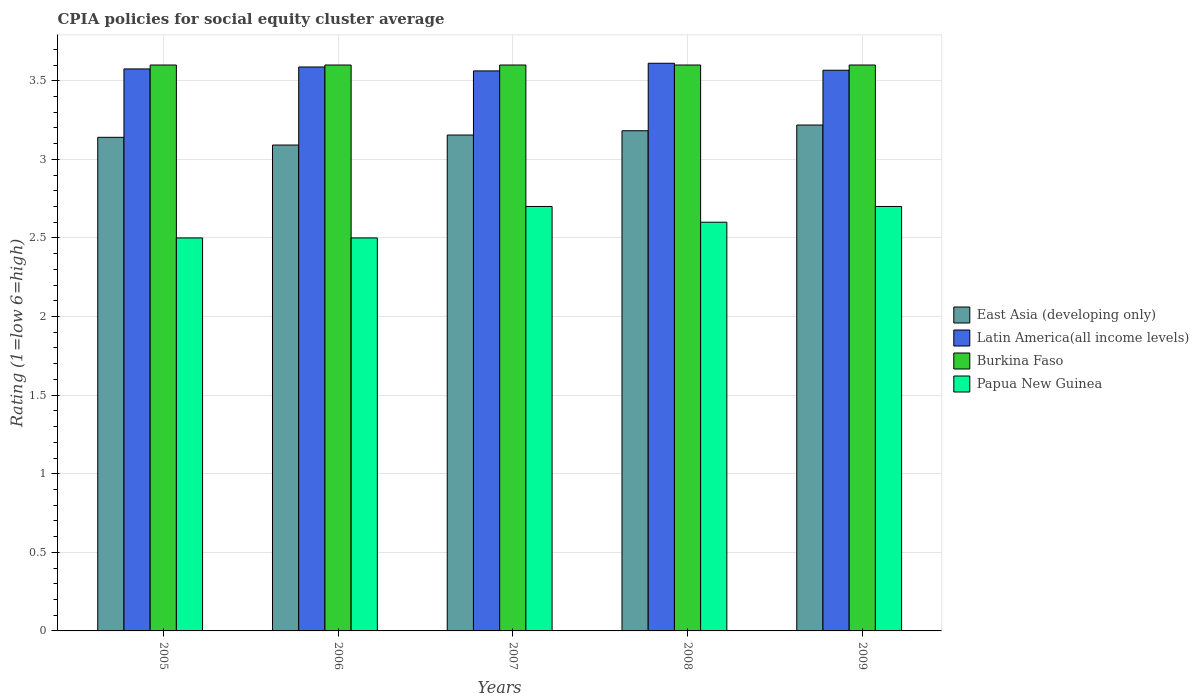How many different coloured bars are there?
Your answer should be compact. 4. How many groups of bars are there?
Your answer should be compact. 5. How many bars are there on the 3rd tick from the left?
Offer a terse response. 4. What is the label of the 4th group of bars from the left?
Give a very brief answer. 2008. In how many cases, is the number of bars for a given year not equal to the number of legend labels?
Provide a succinct answer. 0. In which year was the CPIA rating in Latin America(all income levels) maximum?
Offer a terse response. 2008. What is the total CPIA rating in Latin America(all income levels) in the graph?
Provide a succinct answer. 17.9. What is the difference between the CPIA rating in Burkina Faso in 2005 and that in 2006?
Give a very brief answer. 0. What is the difference between the CPIA rating in Papua New Guinea in 2005 and the CPIA rating in Latin America(all income levels) in 2009?
Offer a terse response. -1.07. In the year 2006, what is the difference between the CPIA rating in Latin America(all income levels) and CPIA rating in Burkina Faso?
Keep it short and to the point. -0.01. What is the ratio of the CPIA rating in Papua New Guinea in 2007 to that in 2008?
Make the answer very short. 1.04. Is the CPIA rating in Latin America(all income levels) in 2005 less than that in 2007?
Make the answer very short. No. Is the difference between the CPIA rating in Latin America(all income levels) in 2005 and 2008 greater than the difference between the CPIA rating in Burkina Faso in 2005 and 2008?
Provide a succinct answer. No. What is the difference between the highest and the second highest CPIA rating in Papua New Guinea?
Provide a succinct answer. 0. What is the difference between the highest and the lowest CPIA rating in Papua New Guinea?
Provide a succinct answer. 0.2. Is it the case that in every year, the sum of the CPIA rating in Papua New Guinea and CPIA rating in Burkina Faso is greater than the sum of CPIA rating in East Asia (developing only) and CPIA rating in Latin America(all income levels)?
Offer a very short reply. No. What does the 3rd bar from the left in 2008 represents?
Ensure brevity in your answer.  Burkina Faso. What does the 2nd bar from the right in 2006 represents?
Your answer should be very brief. Burkina Faso. How many years are there in the graph?
Provide a short and direct response. 5. Are the values on the major ticks of Y-axis written in scientific E-notation?
Your answer should be compact. No. Does the graph contain any zero values?
Your response must be concise. No. Does the graph contain grids?
Provide a succinct answer. Yes. How many legend labels are there?
Provide a succinct answer. 4. How are the legend labels stacked?
Offer a very short reply. Vertical. What is the title of the graph?
Ensure brevity in your answer.  CPIA policies for social equity cluster average. Does "Marshall Islands" appear as one of the legend labels in the graph?
Your response must be concise. No. What is the label or title of the X-axis?
Make the answer very short. Years. What is the label or title of the Y-axis?
Keep it short and to the point. Rating (1=low 6=high). What is the Rating (1=low 6=high) in East Asia (developing only) in 2005?
Give a very brief answer. 3.14. What is the Rating (1=low 6=high) in Latin America(all income levels) in 2005?
Keep it short and to the point. 3.58. What is the Rating (1=low 6=high) in Burkina Faso in 2005?
Provide a succinct answer. 3.6. What is the Rating (1=low 6=high) in Papua New Guinea in 2005?
Provide a short and direct response. 2.5. What is the Rating (1=low 6=high) in East Asia (developing only) in 2006?
Offer a terse response. 3.09. What is the Rating (1=low 6=high) in Latin America(all income levels) in 2006?
Your answer should be very brief. 3.59. What is the Rating (1=low 6=high) of Papua New Guinea in 2006?
Provide a succinct answer. 2.5. What is the Rating (1=low 6=high) in East Asia (developing only) in 2007?
Offer a terse response. 3.15. What is the Rating (1=low 6=high) of Latin America(all income levels) in 2007?
Keep it short and to the point. 3.56. What is the Rating (1=low 6=high) in Burkina Faso in 2007?
Ensure brevity in your answer.  3.6. What is the Rating (1=low 6=high) in East Asia (developing only) in 2008?
Make the answer very short. 3.18. What is the Rating (1=low 6=high) in Latin America(all income levels) in 2008?
Offer a terse response. 3.61. What is the Rating (1=low 6=high) in East Asia (developing only) in 2009?
Provide a succinct answer. 3.22. What is the Rating (1=low 6=high) in Latin America(all income levels) in 2009?
Ensure brevity in your answer.  3.57. What is the Rating (1=low 6=high) of Burkina Faso in 2009?
Give a very brief answer. 3.6. What is the Rating (1=low 6=high) in Papua New Guinea in 2009?
Offer a very short reply. 2.7. Across all years, what is the maximum Rating (1=low 6=high) of East Asia (developing only)?
Offer a very short reply. 3.22. Across all years, what is the maximum Rating (1=low 6=high) of Latin America(all income levels)?
Offer a very short reply. 3.61. Across all years, what is the maximum Rating (1=low 6=high) of Burkina Faso?
Ensure brevity in your answer.  3.6. Across all years, what is the minimum Rating (1=low 6=high) of East Asia (developing only)?
Ensure brevity in your answer.  3.09. Across all years, what is the minimum Rating (1=low 6=high) in Latin America(all income levels)?
Offer a very short reply. 3.56. What is the total Rating (1=low 6=high) of East Asia (developing only) in the graph?
Your response must be concise. 15.79. What is the total Rating (1=low 6=high) of Latin America(all income levels) in the graph?
Offer a terse response. 17.9. What is the difference between the Rating (1=low 6=high) of East Asia (developing only) in 2005 and that in 2006?
Your answer should be compact. 0.05. What is the difference between the Rating (1=low 6=high) in Latin America(all income levels) in 2005 and that in 2006?
Your answer should be very brief. -0.01. What is the difference between the Rating (1=low 6=high) in Burkina Faso in 2005 and that in 2006?
Your answer should be very brief. 0. What is the difference between the Rating (1=low 6=high) in Papua New Guinea in 2005 and that in 2006?
Give a very brief answer. 0. What is the difference between the Rating (1=low 6=high) in East Asia (developing only) in 2005 and that in 2007?
Your answer should be compact. -0.01. What is the difference between the Rating (1=low 6=high) of Latin America(all income levels) in 2005 and that in 2007?
Offer a very short reply. 0.01. What is the difference between the Rating (1=low 6=high) in Burkina Faso in 2005 and that in 2007?
Keep it short and to the point. 0. What is the difference between the Rating (1=low 6=high) in Papua New Guinea in 2005 and that in 2007?
Keep it short and to the point. -0.2. What is the difference between the Rating (1=low 6=high) of East Asia (developing only) in 2005 and that in 2008?
Give a very brief answer. -0.04. What is the difference between the Rating (1=low 6=high) in Latin America(all income levels) in 2005 and that in 2008?
Provide a succinct answer. -0.04. What is the difference between the Rating (1=low 6=high) in Burkina Faso in 2005 and that in 2008?
Give a very brief answer. 0. What is the difference between the Rating (1=low 6=high) in Papua New Guinea in 2005 and that in 2008?
Offer a terse response. -0.1. What is the difference between the Rating (1=low 6=high) in East Asia (developing only) in 2005 and that in 2009?
Keep it short and to the point. -0.08. What is the difference between the Rating (1=low 6=high) of Latin America(all income levels) in 2005 and that in 2009?
Provide a short and direct response. 0.01. What is the difference between the Rating (1=low 6=high) in Burkina Faso in 2005 and that in 2009?
Your response must be concise. 0. What is the difference between the Rating (1=low 6=high) of Papua New Guinea in 2005 and that in 2009?
Your answer should be very brief. -0.2. What is the difference between the Rating (1=low 6=high) of East Asia (developing only) in 2006 and that in 2007?
Offer a very short reply. -0.06. What is the difference between the Rating (1=low 6=high) of Latin America(all income levels) in 2006 and that in 2007?
Keep it short and to the point. 0.03. What is the difference between the Rating (1=low 6=high) of East Asia (developing only) in 2006 and that in 2008?
Make the answer very short. -0.09. What is the difference between the Rating (1=low 6=high) in Latin America(all income levels) in 2006 and that in 2008?
Your answer should be compact. -0.02. What is the difference between the Rating (1=low 6=high) in Burkina Faso in 2006 and that in 2008?
Make the answer very short. 0. What is the difference between the Rating (1=low 6=high) of Papua New Guinea in 2006 and that in 2008?
Provide a short and direct response. -0.1. What is the difference between the Rating (1=low 6=high) of East Asia (developing only) in 2006 and that in 2009?
Offer a very short reply. -0.13. What is the difference between the Rating (1=low 6=high) in Latin America(all income levels) in 2006 and that in 2009?
Your answer should be compact. 0.02. What is the difference between the Rating (1=low 6=high) of East Asia (developing only) in 2007 and that in 2008?
Your answer should be very brief. -0.03. What is the difference between the Rating (1=low 6=high) in Latin America(all income levels) in 2007 and that in 2008?
Your answer should be very brief. -0.05. What is the difference between the Rating (1=low 6=high) in Papua New Guinea in 2007 and that in 2008?
Your answer should be very brief. 0.1. What is the difference between the Rating (1=low 6=high) in East Asia (developing only) in 2007 and that in 2009?
Your response must be concise. -0.06. What is the difference between the Rating (1=low 6=high) in Latin America(all income levels) in 2007 and that in 2009?
Ensure brevity in your answer.  -0. What is the difference between the Rating (1=low 6=high) in Burkina Faso in 2007 and that in 2009?
Your response must be concise. 0. What is the difference between the Rating (1=low 6=high) of Papua New Guinea in 2007 and that in 2009?
Keep it short and to the point. 0. What is the difference between the Rating (1=low 6=high) of East Asia (developing only) in 2008 and that in 2009?
Your answer should be very brief. -0.04. What is the difference between the Rating (1=low 6=high) in Latin America(all income levels) in 2008 and that in 2009?
Offer a very short reply. 0.04. What is the difference between the Rating (1=low 6=high) in Burkina Faso in 2008 and that in 2009?
Make the answer very short. 0. What is the difference between the Rating (1=low 6=high) in Papua New Guinea in 2008 and that in 2009?
Keep it short and to the point. -0.1. What is the difference between the Rating (1=low 6=high) of East Asia (developing only) in 2005 and the Rating (1=low 6=high) of Latin America(all income levels) in 2006?
Provide a succinct answer. -0.45. What is the difference between the Rating (1=low 6=high) in East Asia (developing only) in 2005 and the Rating (1=low 6=high) in Burkina Faso in 2006?
Your answer should be compact. -0.46. What is the difference between the Rating (1=low 6=high) of East Asia (developing only) in 2005 and the Rating (1=low 6=high) of Papua New Guinea in 2006?
Offer a very short reply. 0.64. What is the difference between the Rating (1=low 6=high) of Latin America(all income levels) in 2005 and the Rating (1=low 6=high) of Burkina Faso in 2006?
Give a very brief answer. -0.03. What is the difference between the Rating (1=low 6=high) in Latin America(all income levels) in 2005 and the Rating (1=low 6=high) in Papua New Guinea in 2006?
Make the answer very short. 1.07. What is the difference between the Rating (1=low 6=high) in Burkina Faso in 2005 and the Rating (1=low 6=high) in Papua New Guinea in 2006?
Ensure brevity in your answer.  1.1. What is the difference between the Rating (1=low 6=high) in East Asia (developing only) in 2005 and the Rating (1=low 6=high) in Latin America(all income levels) in 2007?
Give a very brief answer. -0.42. What is the difference between the Rating (1=low 6=high) of East Asia (developing only) in 2005 and the Rating (1=low 6=high) of Burkina Faso in 2007?
Give a very brief answer. -0.46. What is the difference between the Rating (1=low 6=high) of East Asia (developing only) in 2005 and the Rating (1=low 6=high) of Papua New Guinea in 2007?
Provide a short and direct response. 0.44. What is the difference between the Rating (1=low 6=high) in Latin America(all income levels) in 2005 and the Rating (1=low 6=high) in Burkina Faso in 2007?
Offer a very short reply. -0.03. What is the difference between the Rating (1=low 6=high) in Latin America(all income levels) in 2005 and the Rating (1=low 6=high) in Papua New Guinea in 2007?
Provide a succinct answer. 0.88. What is the difference between the Rating (1=low 6=high) of East Asia (developing only) in 2005 and the Rating (1=low 6=high) of Latin America(all income levels) in 2008?
Offer a terse response. -0.47. What is the difference between the Rating (1=low 6=high) of East Asia (developing only) in 2005 and the Rating (1=low 6=high) of Burkina Faso in 2008?
Offer a terse response. -0.46. What is the difference between the Rating (1=low 6=high) in East Asia (developing only) in 2005 and the Rating (1=low 6=high) in Papua New Guinea in 2008?
Offer a very short reply. 0.54. What is the difference between the Rating (1=low 6=high) in Latin America(all income levels) in 2005 and the Rating (1=low 6=high) in Burkina Faso in 2008?
Your answer should be very brief. -0.03. What is the difference between the Rating (1=low 6=high) in Latin America(all income levels) in 2005 and the Rating (1=low 6=high) in Papua New Guinea in 2008?
Give a very brief answer. 0.97. What is the difference between the Rating (1=low 6=high) of East Asia (developing only) in 2005 and the Rating (1=low 6=high) of Latin America(all income levels) in 2009?
Your response must be concise. -0.43. What is the difference between the Rating (1=low 6=high) in East Asia (developing only) in 2005 and the Rating (1=low 6=high) in Burkina Faso in 2009?
Provide a succinct answer. -0.46. What is the difference between the Rating (1=low 6=high) of East Asia (developing only) in 2005 and the Rating (1=low 6=high) of Papua New Guinea in 2009?
Provide a succinct answer. 0.44. What is the difference between the Rating (1=low 6=high) in Latin America(all income levels) in 2005 and the Rating (1=low 6=high) in Burkina Faso in 2009?
Your answer should be very brief. -0.03. What is the difference between the Rating (1=low 6=high) of Latin America(all income levels) in 2005 and the Rating (1=low 6=high) of Papua New Guinea in 2009?
Your answer should be compact. 0.88. What is the difference between the Rating (1=low 6=high) in East Asia (developing only) in 2006 and the Rating (1=low 6=high) in Latin America(all income levels) in 2007?
Your answer should be very brief. -0.47. What is the difference between the Rating (1=low 6=high) in East Asia (developing only) in 2006 and the Rating (1=low 6=high) in Burkina Faso in 2007?
Offer a very short reply. -0.51. What is the difference between the Rating (1=low 6=high) of East Asia (developing only) in 2006 and the Rating (1=low 6=high) of Papua New Guinea in 2007?
Offer a very short reply. 0.39. What is the difference between the Rating (1=low 6=high) in Latin America(all income levels) in 2006 and the Rating (1=low 6=high) in Burkina Faso in 2007?
Provide a succinct answer. -0.01. What is the difference between the Rating (1=low 6=high) in Latin America(all income levels) in 2006 and the Rating (1=low 6=high) in Papua New Guinea in 2007?
Your response must be concise. 0.89. What is the difference between the Rating (1=low 6=high) of Burkina Faso in 2006 and the Rating (1=low 6=high) of Papua New Guinea in 2007?
Offer a very short reply. 0.9. What is the difference between the Rating (1=low 6=high) in East Asia (developing only) in 2006 and the Rating (1=low 6=high) in Latin America(all income levels) in 2008?
Offer a terse response. -0.52. What is the difference between the Rating (1=low 6=high) in East Asia (developing only) in 2006 and the Rating (1=low 6=high) in Burkina Faso in 2008?
Keep it short and to the point. -0.51. What is the difference between the Rating (1=low 6=high) of East Asia (developing only) in 2006 and the Rating (1=low 6=high) of Papua New Guinea in 2008?
Make the answer very short. 0.49. What is the difference between the Rating (1=low 6=high) of Latin America(all income levels) in 2006 and the Rating (1=low 6=high) of Burkina Faso in 2008?
Your response must be concise. -0.01. What is the difference between the Rating (1=low 6=high) in Latin America(all income levels) in 2006 and the Rating (1=low 6=high) in Papua New Guinea in 2008?
Your answer should be compact. 0.99. What is the difference between the Rating (1=low 6=high) in East Asia (developing only) in 2006 and the Rating (1=low 6=high) in Latin America(all income levels) in 2009?
Keep it short and to the point. -0.48. What is the difference between the Rating (1=low 6=high) of East Asia (developing only) in 2006 and the Rating (1=low 6=high) of Burkina Faso in 2009?
Offer a terse response. -0.51. What is the difference between the Rating (1=low 6=high) in East Asia (developing only) in 2006 and the Rating (1=low 6=high) in Papua New Guinea in 2009?
Your response must be concise. 0.39. What is the difference between the Rating (1=low 6=high) of Latin America(all income levels) in 2006 and the Rating (1=low 6=high) of Burkina Faso in 2009?
Make the answer very short. -0.01. What is the difference between the Rating (1=low 6=high) in Latin America(all income levels) in 2006 and the Rating (1=low 6=high) in Papua New Guinea in 2009?
Keep it short and to the point. 0.89. What is the difference between the Rating (1=low 6=high) of East Asia (developing only) in 2007 and the Rating (1=low 6=high) of Latin America(all income levels) in 2008?
Keep it short and to the point. -0.46. What is the difference between the Rating (1=low 6=high) of East Asia (developing only) in 2007 and the Rating (1=low 6=high) of Burkina Faso in 2008?
Give a very brief answer. -0.45. What is the difference between the Rating (1=low 6=high) in East Asia (developing only) in 2007 and the Rating (1=low 6=high) in Papua New Guinea in 2008?
Your response must be concise. 0.55. What is the difference between the Rating (1=low 6=high) in Latin America(all income levels) in 2007 and the Rating (1=low 6=high) in Burkina Faso in 2008?
Ensure brevity in your answer.  -0.04. What is the difference between the Rating (1=low 6=high) in Latin America(all income levels) in 2007 and the Rating (1=low 6=high) in Papua New Guinea in 2008?
Ensure brevity in your answer.  0.96. What is the difference between the Rating (1=low 6=high) of East Asia (developing only) in 2007 and the Rating (1=low 6=high) of Latin America(all income levels) in 2009?
Your answer should be very brief. -0.41. What is the difference between the Rating (1=low 6=high) of East Asia (developing only) in 2007 and the Rating (1=low 6=high) of Burkina Faso in 2009?
Provide a short and direct response. -0.45. What is the difference between the Rating (1=low 6=high) in East Asia (developing only) in 2007 and the Rating (1=low 6=high) in Papua New Guinea in 2009?
Ensure brevity in your answer.  0.45. What is the difference between the Rating (1=low 6=high) in Latin America(all income levels) in 2007 and the Rating (1=low 6=high) in Burkina Faso in 2009?
Make the answer very short. -0.04. What is the difference between the Rating (1=low 6=high) of Latin America(all income levels) in 2007 and the Rating (1=low 6=high) of Papua New Guinea in 2009?
Keep it short and to the point. 0.86. What is the difference between the Rating (1=low 6=high) of East Asia (developing only) in 2008 and the Rating (1=low 6=high) of Latin America(all income levels) in 2009?
Ensure brevity in your answer.  -0.38. What is the difference between the Rating (1=low 6=high) in East Asia (developing only) in 2008 and the Rating (1=low 6=high) in Burkina Faso in 2009?
Offer a very short reply. -0.42. What is the difference between the Rating (1=low 6=high) of East Asia (developing only) in 2008 and the Rating (1=low 6=high) of Papua New Guinea in 2009?
Your answer should be compact. 0.48. What is the difference between the Rating (1=low 6=high) in Latin America(all income levels) in 2008 and the Rating (1=low 6=high) in Burkina Faso in 2009?
Provide a short and direct response. 0.01. What is the difference between the Rating (1=low 6=high) of Latin America(all income levels) in 2008 and the Rating (1=low 6=high) of Papua New Guinea in 2009?
Your answer should be compact. 0.91. What is the average Rating (1=low 6=high) of East Asia (developing only) per year?
Give a very brief answer. 3.16. What is the average Rating (1=low 6=high) of Latin America(all income levels) per year?
Your answer should be compact. 3.58. In the year 2005, what is the difference between the Rating (1=low 6=high) of East Asia (developing only) and Rating (1=low 6=high) of Latin America(all income levels)?
Keep it short and to the point. -0.43. In the year 2005, what is the difference between the Rating (1=low 6=high) in East Asia (developing only) and Rating (1=low 6=high) in Burkina Faso?
Offer a very short reply. -0.46. In the year 2005, what is the difference between the Rating (1=low 6=high) in East Asia (developing only) and Rating (1=low 6=high) in Papua New Guinea?
Keep it short and to the point. 0.64. In the year 2005, what is the difference between the Rating (1=low 6=high) of Latin America(all income levels) and Rating (1=low 6=high) of Burkina Faso?
Make the answer very short. -0.03. In the year 2005, what is the difference between the Rating (1=low 6=high) of Latin America(all income levels) and Rating (1=low 6=high) of Papua New Guinea?
Your answer should be very brief. 1.07. In the year 2005, what is the difference between the Rating (1=low 6=high) of Burkina Faso and Rating (1=low 6=high) of Papua New Guinea?
Your response must be concise. 1.1. In the year 2006, what is the difference between the Rating (1=low 6=high) of East Asia (developing only) and Rating (1=low 6=high) of Latin America(all income levels)?
Give a very brief answer. -0.5. In the year 2006, what is the difference between the Rating (1=low 6=high) of East Asia (developing only) and Rating (1=low 6=high) of Burkina Faso?
Your answer should be very brief. -0.51. In the year 2006, what is the difference between the Rating (1=low 6=high) of East Asia (developing only) and Rating (1=low 6=high) of Papua New Guinea?
Give a very brief answer. 0.59. In the year 2006, what is the difference between the Rating (1=low 6=high) of Latin America(all income levels) and Rating (1=low 6=high) of Burkina Faso?
Your answer should be compact. -0.01. In the year 2006, what is the difference between the Rating (1=low 6=high) of Latin America(all income levels) and Rating (1=low 6=high) of Papua New Guinea?
Keep it short and to the point. 1.09. In the year 2007, what is the difference between the Rating (1=low 6=high) in East Asia (developing only) and Rating (1=low 6=high) in Latin America(all income levels)?
Provide a short and direct response. -0.41. In the year 2007, what is the difference between the Rating (1=low 6=high) of East Asia (developing only) and Rating (1=low 6=high) of Burkina Faso?
Ensure brevity in your answer.  -0.45. In the year 2007, what is the difference between the Rating (1=low 6=high) of East Asia (developing only) and Rating (1=low 6=high) of Papua New Guinea?
Keep it short and to the point. 0.45. In the year 2007, what is the difference between the Rating (1=low 6=high) in Latin America(all income levels) and Rating (1=low 6=high) in Burkina Faso?
Ensure brevity in your answer.  -0.04. In the year 2007, what is the difference between the Rating (1=low 6=high) in Latin America(all income levels) and Rating (1=low 6=high) in Papua New Guinea?
Keep it short and to the point. 0.86. In the year 2008, what is the difference between the Rating (1=low 6=high) of East Asia (developing only) and Rating (1=low 6=high) of Latin America(all income levels)?
Provide a short and direct response. -0.43. In the year 2008, what is the difference between the Rating (1=low 6=high) of East Asia (developing only) and Rating (1=low 6=high) of Burkina Faso?
Provide a short and direct response. -0.42. In the year 2008, what is the difference between the Rating (1=low 6=high) in East Asia (developing only) and Rating (1=low 6=high) in Papua New Guinea?
Provide a succinct answer. 0.58. In the year 2008, what is the difference between the Rating (1=low 6=high) of Latin America(all income levels) and Rating (1=low 6=high) of Burkina Faso?
Keep it short and to the point. 0.01. In the year 2008, what is the difference between the Rating (1=low 6=high) of Latin America(all income levels) and Rating (1=low 6=high) of Papua New Guinea?
Offer a very short reply. 1.01. In the year 2009, what is the difference between the Rating (1=low 6=high) in East Asia (developing only) and Rating (1=low 6=high) in Latin America(all income levels)?
Offer a terse response. -0.35. In the year 2009, what is the difference between the Rating (1=low 6=high) in East Asia (developing only) and Rating (1=low 6=high) in Burkina Faso?
Your response must be concise. -0.38. In the year 2009, what is the difference between the Rating (1=low 6=high) in East Asia (developing only) and Rating (1=low 6=high) in Papua New Guinea?
Your response must be concise. 0.52. In the year 2009, what is the difference between the Rating (1=low 6=high) in Latin America(all income levels) and Rating (1=low 6=high) in Burkina Faso?
Ensure brevity in your answer.  -0.03. In the year 2009, what is the difference between the Rating (1=low 6=high) of Latin America(all income levels) and Rating (1=low 6=high) of Papua New Guinea?
Ensure brevity in your answer.  0.87. In the year 2009, what is the difference between the Rating (1=low 6=high) in Burkina Faso and Rating (1=low 6=high) in Papua New Guinea?
Your answer should be very brief. 0.9. What is the ratio of the Rating (1=low 6=high) of East Asia (developing only) in 2005 to that in 2006?
Your response must be concise. 1.02. What is the ratio of the Rating (1=low 6=high) of Burkina Faso in 2005 to that in 2006?
Ensure brevity in your answer.  1. What is the ratio of the Rating (1=low 6=high) in Latin America(all income levels) in 2005 to that in 2007?
Offer a very short reply. 1. What is the ratio of the Rating (1=low 6=high) in Papua New Guinea in 2005 to that in 2007?
Give a very brief answer. 0.93. What is the ratio of the Rating (1=low 6=high) of East Asia (developing only) in 2005 to that in 2008?
Keep it short and to the point. 0.99. What is the ratio of the Rating (1=low 6=high) in Latin America(all income levels) in 2005 to that in 2008?
Your answer should be compact. 0.99. What is the ratio of the Rating (1=low 6=high) of Burkina Faso in 2005 to that in 2008?
Your response must be concise. 1. What is the ratio of the Rating (1=low 6=high) in Papua New Guinea in 2005 to that in 2008?
Keep it short and to the point. 0.96. What is the ratio of the Rating (1=low 6=high) in East Asia (developing only) in 2005 to that in 2009?
Give a very brief answer. 0.98. What is the ratio of the Rating (1=low 6=high) in Latin America(all income levels) in 2005 to that in 2009?
Your answer should be compact. 1. What is the ratio of the Rating (1=low 6=high) in Papua New Guinea in 2005 to that in 2009?
Your answer should be compact. 0.93. What is the ratio of the Rating (1=low 6=high) in East Asia (developing only) in 2006 to that in 2007?
Provide a succinct answer. 0.98. What is the ratio of the Rating (1=low 6=high) of Papua New Guinea in 2006 to that in 2007?
Ensure brevity in your answer.  0.93. What is the ratio of the Rating (1=low 6=high) of East Asia (developing only) in 2006 to that in 2008?
Give a very brief answer. 0.97. What is the ratio of the Rating (1=low 6=high) in Papua New Guinea in 2006 to that in 2008?
Offer a very short reply. 0.96. What is the ratio of the Rating (1=low 6=high) of East Asia (developing only) in 2006 to that in 2009?
Offer a very short reply. 0.96. What is the ratio of the Rating (1=low 6=high) in Latin America(all income levels) in 2006 to that in 2009?
Give a very brief answer. 1.01. What is the ratio of the Rating (1=low 6=high) in Burkina Faso in 2006 to that in 2009?
Your answer should be compact. 1. What is the ratio of the Rating (1=low 6=high) of Papua New Guinea in 2006 to that in 2009?
Offer a terse response. 0.93. What is the ratio of the Rating (1=low 6=high) of Latin America(all income levels) in 2007 to that in 2008?
Keep it short and to the point. 0.99. What is the ratio of the Rating (1=low 6=high) of Burkina Faso in 2007 to that in 2008?
Your answer should be very brief. 1. What is the ratio of the Rating (1=low 6=high) of Papua New Guinea in 2007 to that in 2008?
Make the answer very short. 1.04. What is the ratio of the Rating (1=low 6=high) of East Asia (developing only) in 2007 to that in 2009?
Your answer should be compact. 0.98. What is the ratio of the Rating (1=low 6=high) in Latin America(all income levels) in 2007 to that in 2009?
Offer a terse response. 1. What is the ratio of the Rating (1=low 6=high) in Burkina Faso in 2007 to that in 2009?
Make the answer very short. 1. What is the ratio of the Rating (1=low 6=high) in Papua New Guinea in 2007 to that in 2009?
Give a very brief answer. 1. What is the ratio of the Rating (1=low 6=high) of East Asia (developing only) in 2008 to that in 2009?
Keep it short and to the point. 0.99. What is the ratio of the Rating (1=low 6=high) in Latin America(all income levels) in 2008 to that in 2009?
Give a very brief answer. 1.01. What is the difference between the highest and the second highest Rating (1=low 6=high) in East Asia (developing only)?
Make the answer very short. 0.04. What is the difference between the highest and the second highest Rating (1=low 6=high) in Latin America(all income levels)?
Give a very brief answer. 0.02. What is the difference between the highest and the second highest Rating (1=low 6=high) in Papua New Guinea?
Provide a short and direct response. 0. What is the difference between the highest and the lowest Rating (1=low 6=high) in East Asia (developing only)?
Offer a terse response. 0.13. What is the difference between the highest and the lowest Rating (1=low 6=high) of Latin America(all income levels)?
Keep it short and to the point. 0.05. 